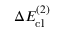Convert formula to latex. <formula><loc_0><loc_0><loc_500><loc_500>\Delta E _ { c l } ^ { ( 2 ) }</formula> 